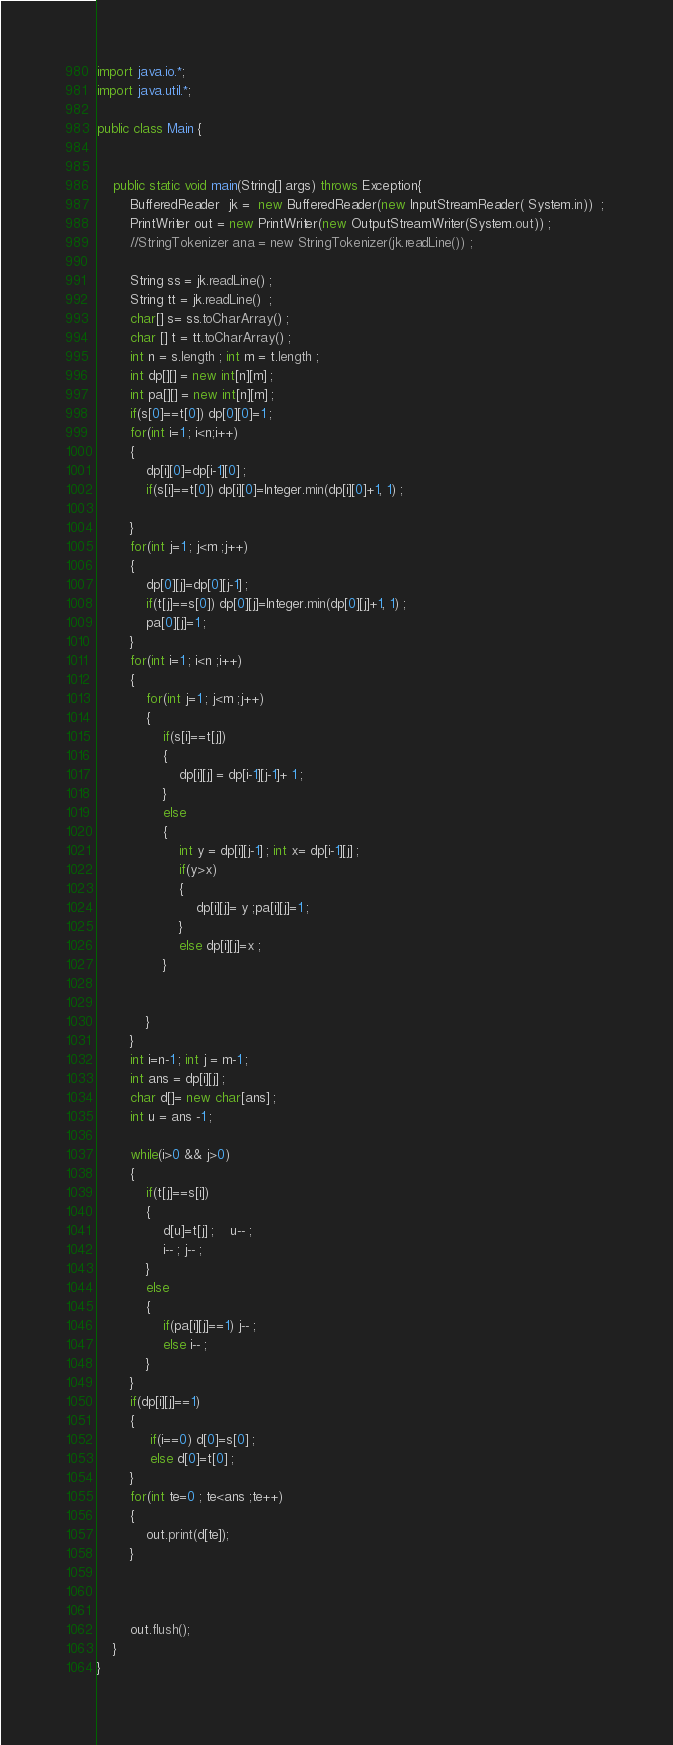<code> <loc_0><loc_0><loc_500><loc_500><_Java_>import java.io.*;
import java.util.*;

public class Main {


	public static void main(String[] args) throws Exception{
		BufferedReader  jk =  new BufferedReader(new InputStreamReader( System.in))  ; 
		PrintWriter out = new PrintWriter(new OutputStreamWriter(System.out)) ; 
		//StringTokenizer ana = new StringTokenizer(jk.readLine()) ;

		String ss = jk.readLine() ; 
		String tt = jk.readLine()  ; 
		char[] s= ss.toCharArray() ; 
		char [] t = tt.toCharArray() ; 
		int n = s.length ; int m = t.length ; 
		int dp[][] = new int[n][m] ; 
		int pa[][] = new int[n][m] ; 
		if(s[0]==t[0]) dp[0][0]=1 ; 
		for(int i=1 ; i<n;i++)
		{
			dp[i][0]=dp[i-1][0] ; 
			if(s[i]==t[0]) dp[i][0]=Integer.min(dp[i][0]+1, 1) ;

		}
		for(int j=1 ; j<m ;j++)
		{
			dp[0][j]=dp[0][j-1] ; 
			if(t[j]==s[0]) dp[0][j]=Integer.min(dp[0][j]+1, 1) ;
			pa[0][j]=1 ;
		}
		for(int i=1 ; i<n ;i++)
		{
			for(int j=1 ; j<m ;j++)
			{
				if(s[i]==t[j])
				{
					dp[i][j] = dp[i-1][j-1]+ 1 ; 
				}
				else
				{
					int y = dp[i][j-1] ; int x= dp[i-1][j] ; 
					if(y>x)
					{
						dp[i][j]= y ;pa[i][j]=1 ;
					}
					else dp[i][j]=x ; 
				}


			}
		}
		int i=n-1 ; int j = m-1 ; 
		int ans = dp[i][j] ; 
		char d[]= new char[ans] ; 
		int u = ans -1 ;

		while(i>0 && j>0)
		{
			if(t[j]==s[i]) 
			{
				d[u]=t[j] ;    u-- ; 	
				i-- ; j-- ;
			}
			else
			{
				if(pa[i][j]==1) j-- ; 
				else i-- ; 
			}	
		}
		if(dp[i][j]==1)
		{
             if(i==0) d[0]=s[0] ; 
             else d[0]=t[0] ; 
		}
		for(int te=0 ; te<ans ;te++)
		{
			out.print(d[te]);
		}



		out.flush();
	}
}

</code> 